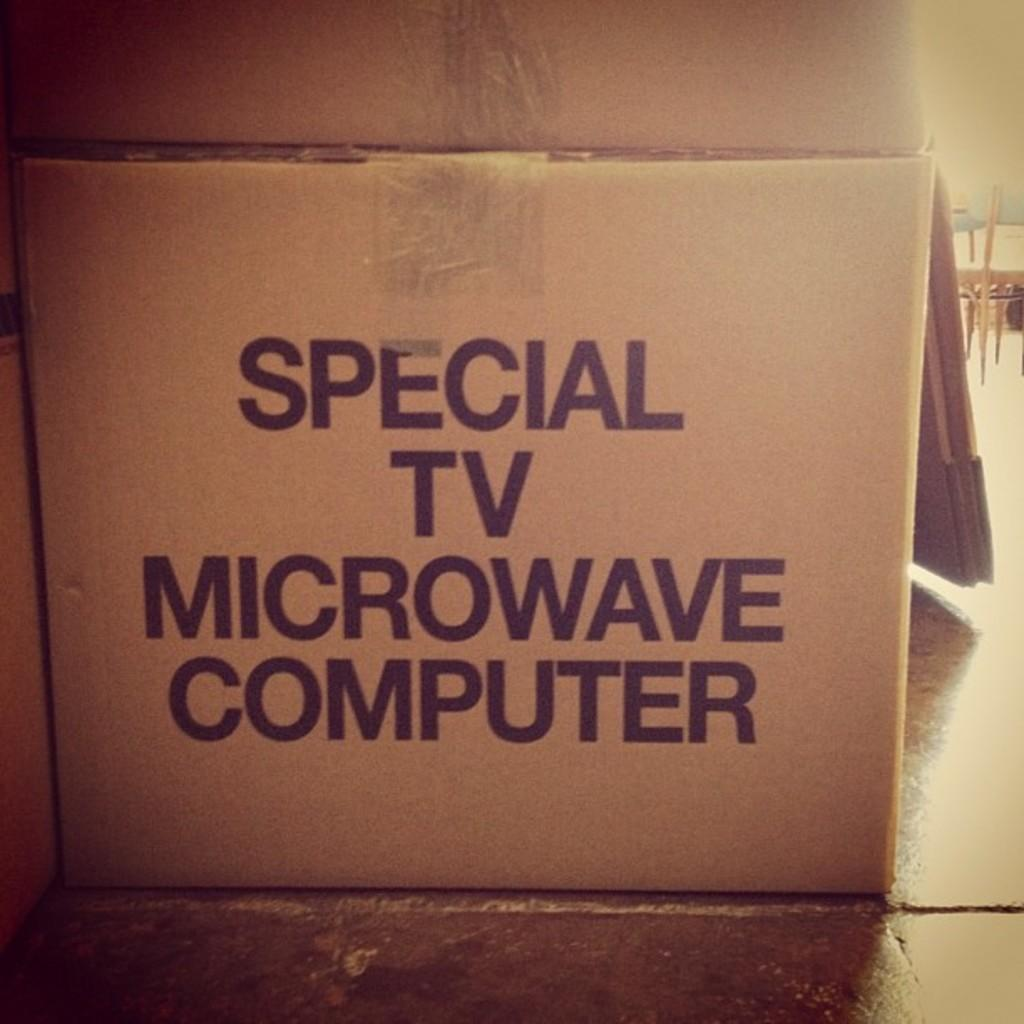Provide a one-sentence caption for the provided image. a brown cardboard box for special tv microwave computers. 